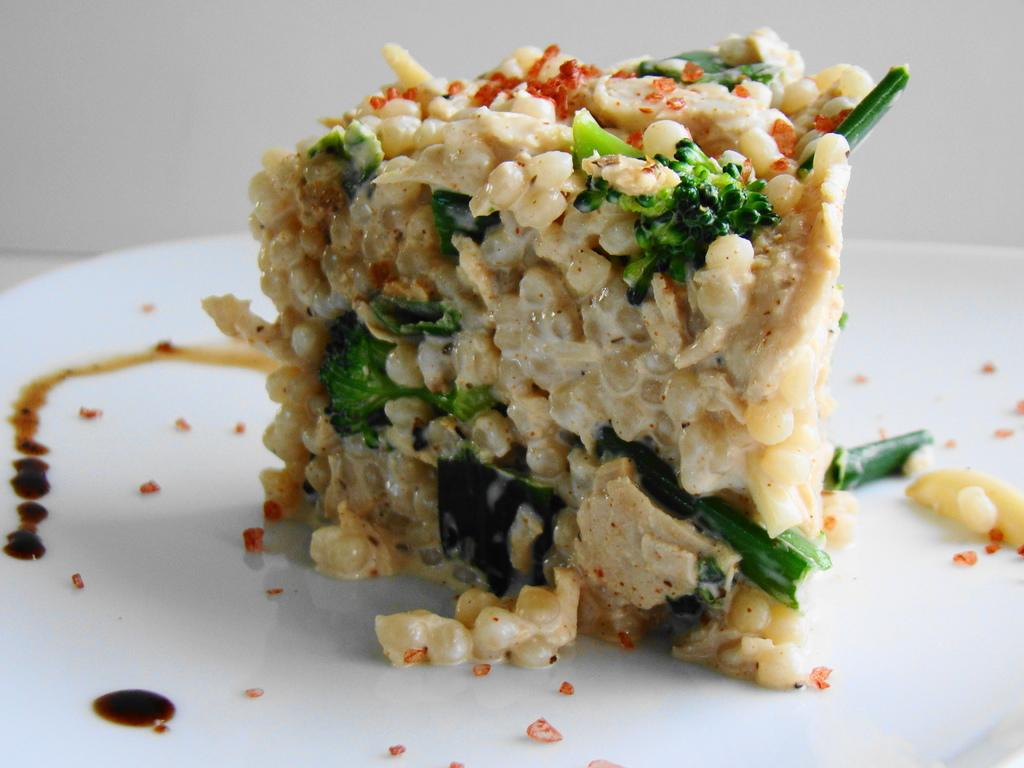What is on the plate in the image? There is food in the plate in the image. What can be seen behind the plate in the image? There is a wall visible in the background of the image. What type of pest can be seen crawling on the food in the image? There is no pest visible on the food in the image. What news headline is displayed on the wall in the image? There is no news headline visible on the wall in the image. 